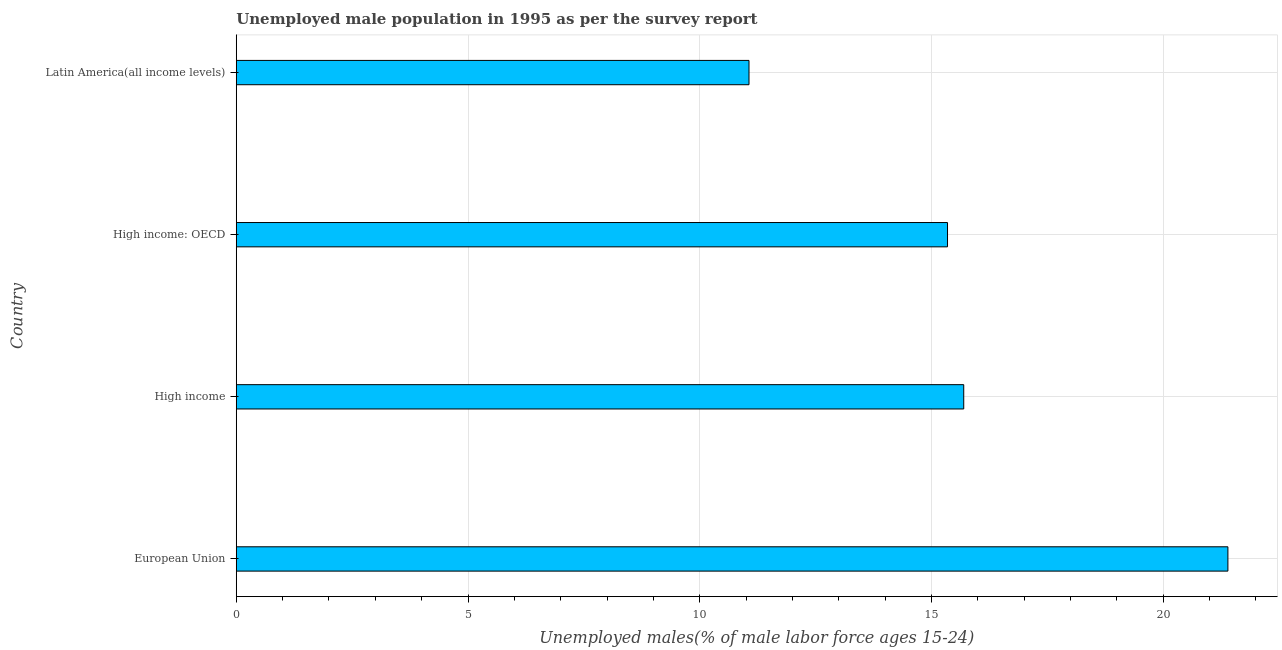Does the graph contain any zero values?
Offer a terse response. No. Does the graph contain grids?
Offer a terse response. Yes. What is the title of the graph?
Your response must be concise. Unemployed male population in 1995 as per the survey report. What is the label or title of the X-axis?
Your answer should be compact. Unemployed males(% of male labor force ages 15-24). What is the unemployed male youth in High income: OECD?
Provide a short and direct response. 15.35. Across all countries, what is the maximum unemployed male youth?
Your answer should be very brief. 21.4. Across all countries, what is the minimum unemployed male youth?
Provide a succinct answer. 11.06. In which country was the unemployed male youth maximum?
Offer a terse response. European Union. In which country was the unemployed male youth minimum?
Your answer should be compact. Latin America(all income levels). What is the sum of the unemployed male youth?
Make the answer very short. 63.5. What is the difference between the unemployed male youth in High income and High income: OECD?
Offer a terse response. 0.35. What is the average unemployed male youth per country?
Provide a succinct answer. 15.88. What is the median unemployed male youth?
Make the answer very short. 15.52. What is the ratio of the unemployed male youth in High income to that in Latin America(all income levels)?
Your response must be concise. 1.42. Is the unemployed male youth in High income less than that in High income: OECD?
Your answer should be very brief. No. What is the difference between the highest and the lowest unemployed male youth?
Provide a short and direct response. 10.33. In how many countries, is the unemployed male youth greater than the average unemployed male youth taken over all countries?
Provide a short and direct response. 1. How many bars are there?
Make the answer very short. 4. What is the difference between two consecutive major ticks on the X-axis?
Make the answer very short. 5. Are the values on the major ticks of X-axis written in scientific E-notation?
Provide a succinct answer. No. What is the Unemployed males(% of male labor force ages 15-24) of European Union?
Offer a very short reply. 21.4. What is the Unemployed males(% of male labor force ages 15-24) of High income?
Give a very brief answer. 15.7. What is the Unemployed males(% of male labor force ages 15-24) in High income: OECD?
Offer a very short reply. 15.35. What is the Unemployed males(% of male labor force ages 15-24) of Latin America(all income levels)?
Provide a short and direct response. 11.06. What is the difference between the Unemployed males(% of male labor force ages 15-24) in European Union and High income?
Ensure brevity in your answer.  5.7. What is the difference between the Unemployed males(% of male labor force ages 15-24) in European Union and High income: OECD?
Offer a terse response. 6.05. What is the difference between the Unemployed males(% of male labor force ages 15-24) in European Union and Latin America(all income levels)?
Keep it short and to the point. 10.33. What is the difference between the Unemployed males(% of male labor force ages 15-24) in High income and High income: OECD?
Offer a very short reply. 0.35. What is the difference between the Unemployed males(% of male labor force ages 15-24) in High income and Latin America(all income levels)?
Your answer should be very brief. 4.63. What is the difference between the Unemployed males(% of male labor force ages 15-24) in High income: OECD and Latin America(all income levels)?
Offer a terse response. 4.28. What is the ratio of the Unemployed males(% of male labor force ages 15-24) in European Union to that in High income?
Offer a terse response. 1.36. What is the ratio of the Unemployed males(% of male labor force ages 15-24) in European Union to that in High income: OECD?
Provide a succinct answer. 1.39. What is the ratio of the Unemployed males(% of male labor force ages 15-24) in European Union to that in Latin America(all income levels)?
Give a very brief answer. 1.93. What is the ratio of the Unemployed males(% of male labor force ages 15-24) in High income to that in Latin America(all income levels)?
Your response must be concise. 1.42. What is the ratio of the Unemployed males(% of male labor force ages 15-24) in High income: OECD to that in Latin America(all income levels)?
Your answer should be compact. 1.39. 